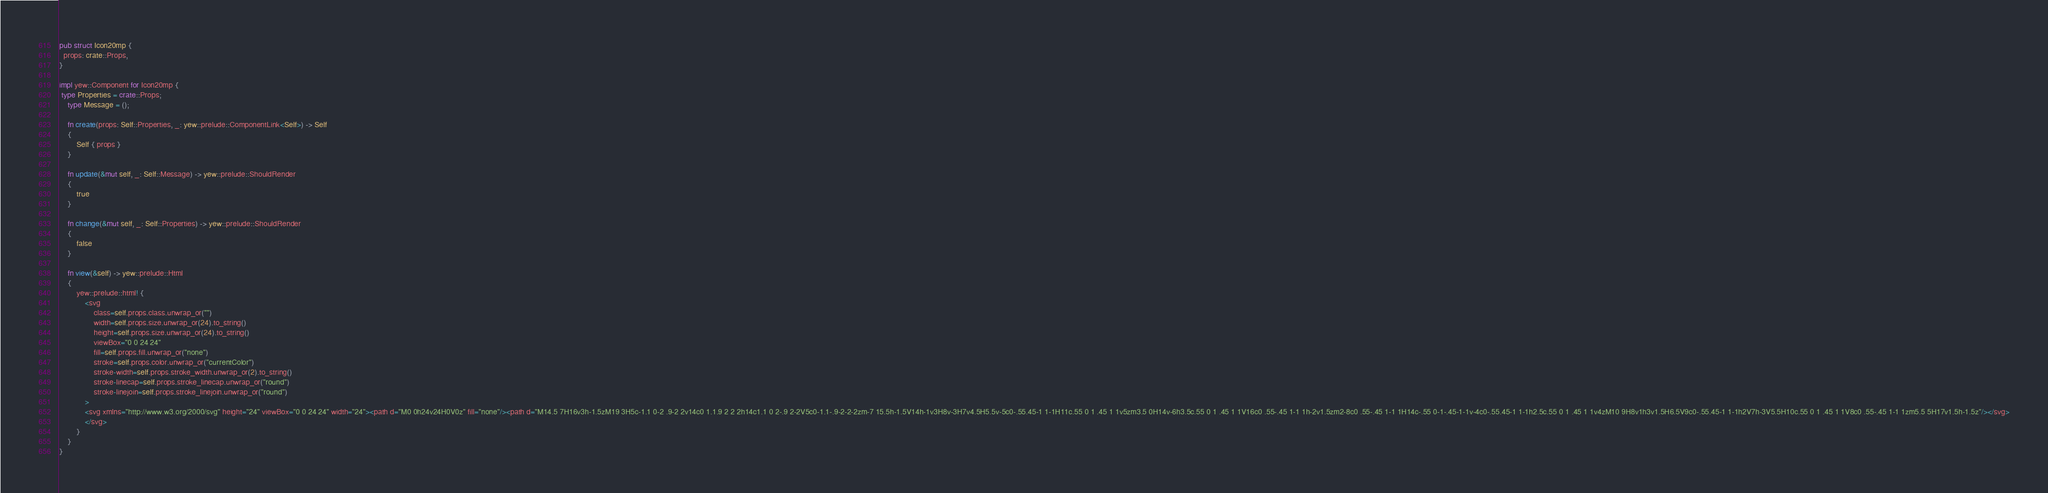Convert code to text. <code><loc_0><loc_0><loc_500><loc_500><_Rust_>
pub struct Icon20mp {
  props: crate::Props,
}

impl yew::Component for Icon20mp {
 type Properties = crate::Props;
    type Message = ();

    fn create(props: Self::Properties, _: yew::prelude::ComponentLink<Self>) -> Self
    {
        Self { props }
    }

    fn update(&mut self, _: Self::Message) -> yew::prelude::ShouldRender
    {
        true
    }

    fn change(&mut self, _: Self::Properties) -> yew::prelude::ShouldRender
    {
        false
    }

    fn view(&self) -> yew::prelude::Html
    {
        yew::prelude::html! {
            <svg
                class=self.props.class.unwrap_or("")
                width=self.props.size.unwrap_or(24).to_string()
                height=self.props.size.unwrap_or(24).to_string()
                viewBox="0 0 24 24"
                fill=self.props.fill.unwrap_or("none")
                stroke=self.props.color.unwrap_or("currentColor")
                stroke-width=self.props.stroke_width.unwrap_or(2).to_string()
                stroke-linecap=self.props.stroke_linecap.unwrap_or("round")
                stroke-linejoin=self.props.stroke_linejoin.unwrap_or("round")
            >
            <svg xmlns="http://www.w3.org/2000/svg" height="24" viewBox="0 0 24 24" width="24"><path d="M0 0h24v24H0V0z" fill="none"/><path d="M14.5 7H16v3h-1.5zM19 3H5c-1.1 0-2 .9-2 2v14c0 1.1.9 2 2 2h14c1.1 0 2-.9 2-2V5c0-1.1-.9-2-2-2zm-7 15.5h-1.5V14h-1v3H8v-3H7v4.5H5.5v-5c0-.55.45-1 1-1H11c.55 0 1 .45 1 1v5zm3.5 0H14v-6h3.5c.55 0 1 .45 1 1V16c0 .55-.45 1-1 1h-2v1.5zm2-8c0 .55-.45 1-1 1H14c-.55 0-1-.45-1-1v-4c0-.55.45-1 1-1h2.5c.55 0 1 .45 1 1v4zM10 9H8v1h3v1.5H6.5V9c0-.55.45-1 1-1h2V7h-3V5.5H10c.55 0 1 .45 1 1V8c0 .55-.45 1-1 1zm5.5 5H17v1.5h-1.5z"/></svg>
            </svg>
        }
    }
}


</code> 